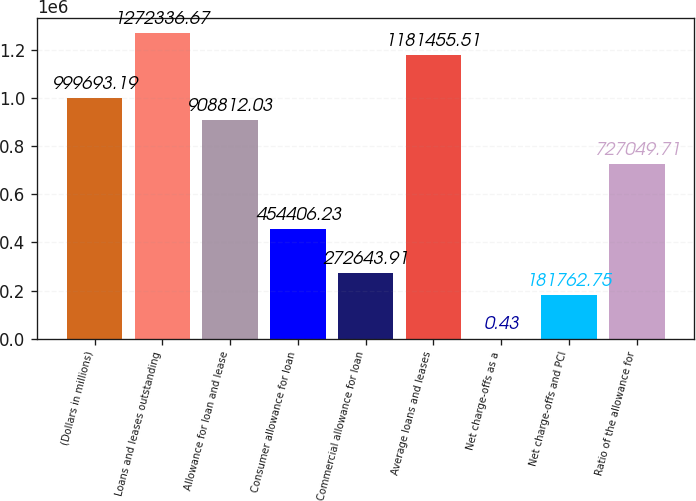<chart> <loc_0><loc_0><loc_500><loc_500><bar_chart><fcel>(Dollars in millions)<fcel>Loans and leases outstanding<fcel>Allowance for loan and lease<fcel>Consumer allowance for loan<fcel>Commercial allowance for loan<fcel>Average loans and leases<fcel>Net charge-offs as a<fcel>Net charge-offs and PCI<fcel>Ratio of the allowance for<nl><fcel>999693<fcel>1.27234e+06<fcel>908812<fcel>454406<fcel>272644<fcel>1.18146e+06<fcel>0.43<fcel>181763<fcel>727050<nl></chart> 